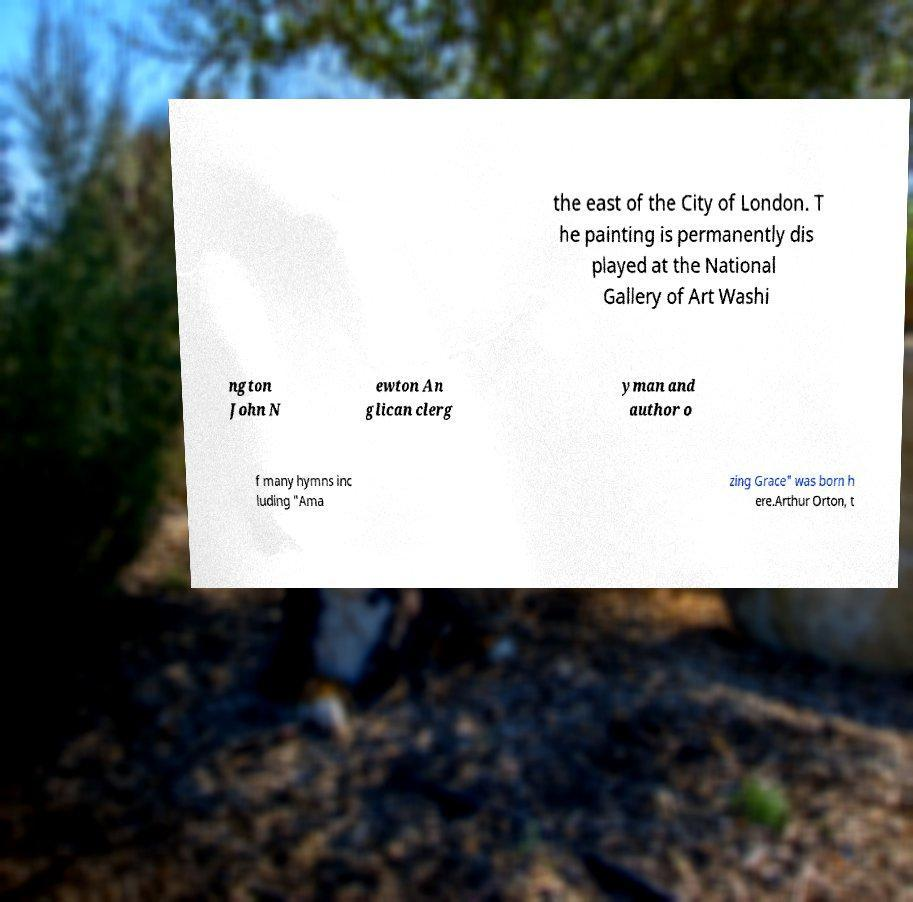Could you assist in decoding the text presented in this image and type it out clearly? the east of the City of London. T he painting is permanently dis played at the National Gallery of Art Washi ngton John N ewton An glican clerg yman and author o f many hymns inc luding "Ama zing Grace" was born h ere.Arthur Orton, t 